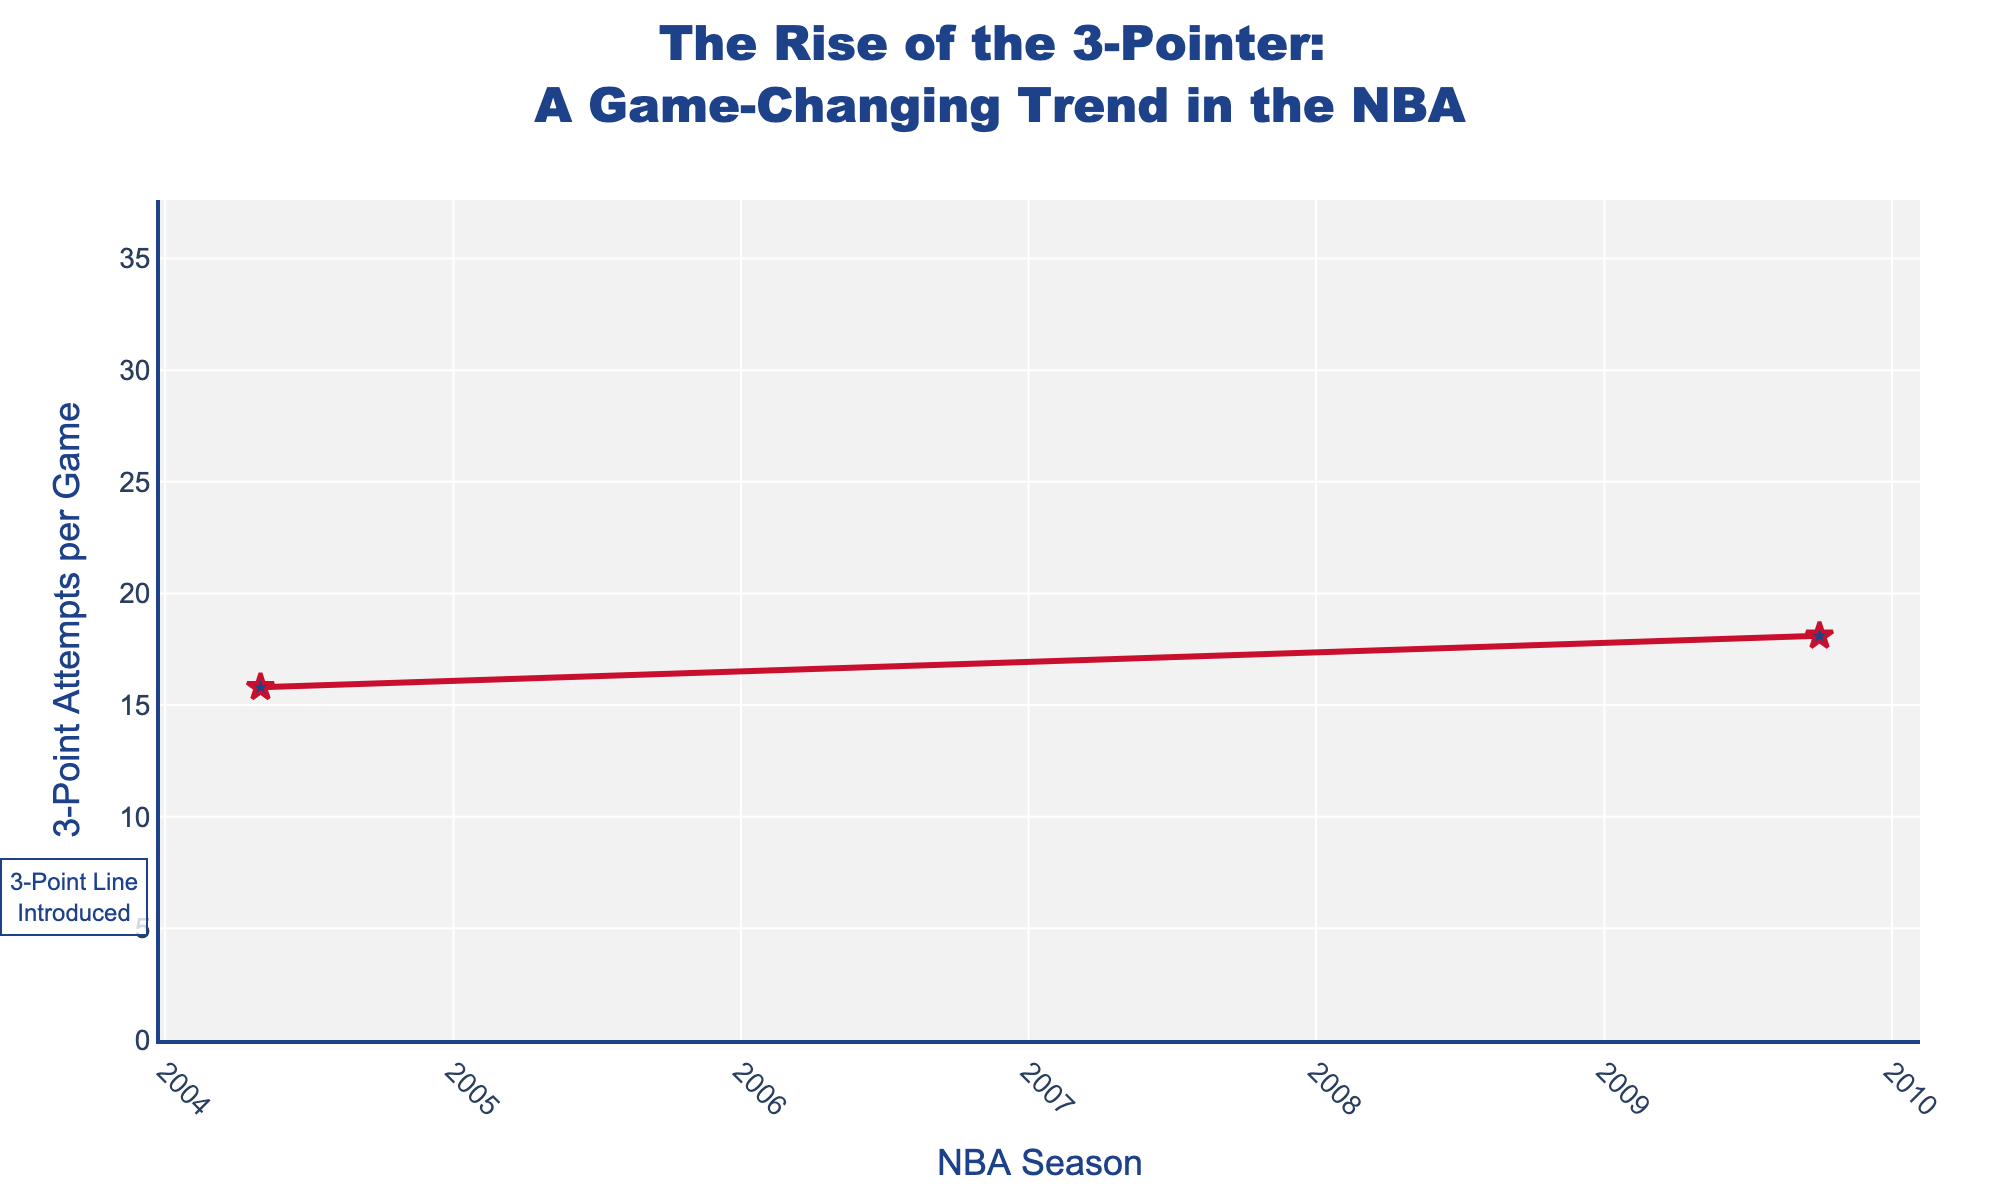Which NBA season showed the highest number of 3-point shot attempts per game? The highest 3-point shot attempts per game is 34.2, and this value corresponds to the 2022-23 season as indicated in the figure.
Answer: 2022-23 How did the number of 3-point attempts per game compare between the 1989-90 and 1994-95 seasons? In the 1989-90 season, the number of 3-point attempts per game was 6.6, whereas in the 1994-95 season, it was 15.3. By subtracting 6.6 from 15.3, the increase is 8.7.
Answer: More in 1994-95 by 8.7 What is the average number of 3-point attempts per game from 1979-80 to 2022-23? Adding the values (2.8 + 3.1 + 6.6 + 15.3 + 13.7 + 15.8 + 18.1 + 22.4 + 34.1 + 34.2) gives a total of 166.1. There are 10 seasons recorded in the data, so the average is 166.1/10 = 16.61.
Answer: 16.61 During which period did the number of 3-point shot attempts per game experience the fastest rise? The biggest increase occurred between 2014-15 and 2019-20: from 22.4 to 34.1, which is a change of 34.1 - 22.4 = 11.7 in just five years.
Answer: 2014-15 to 2019-20 What trend is observed in the 3-point attempts from 1994-95 to 1999-00? The number of 3-point attempts per game dropped from 15.3 in the 1994-95 season to 13.7 in the 1999-00 season, indicating a downward trend.
Answer: Decreasing What is the percentage increase in 3-point attempts per game from 2004-05 to 2022-23? The 3-point attempts per game in 2004-05 were 15.8, and in 2022-23 they were 34.2. The percentage increase is calculated as ((34.2 - 15.8) / 15.8) * 100% = 116.46%.
Answer: 116.46% Which season had the least 3-point attempts per game, and how many attempts were made? The season with the least 3-point attempts per game is 1979-80 with 2.8 attempts.
Answer: 1979-80, 2.8 attempts What is the change in 3-point attempts per game between the seasons 2009-10 and 2014-15? In 2009-10, there were 18.1 attempts per game, and in 2014-15, there were 22.4 attempts per game. The change is 22.4 - 18.1 = 4.3.
Answer: Increase by 4.3 What color and symbol are used for the markers on the line plot? The markers on the line plot are stars and are colored blue.
Answer: Blue star markers 